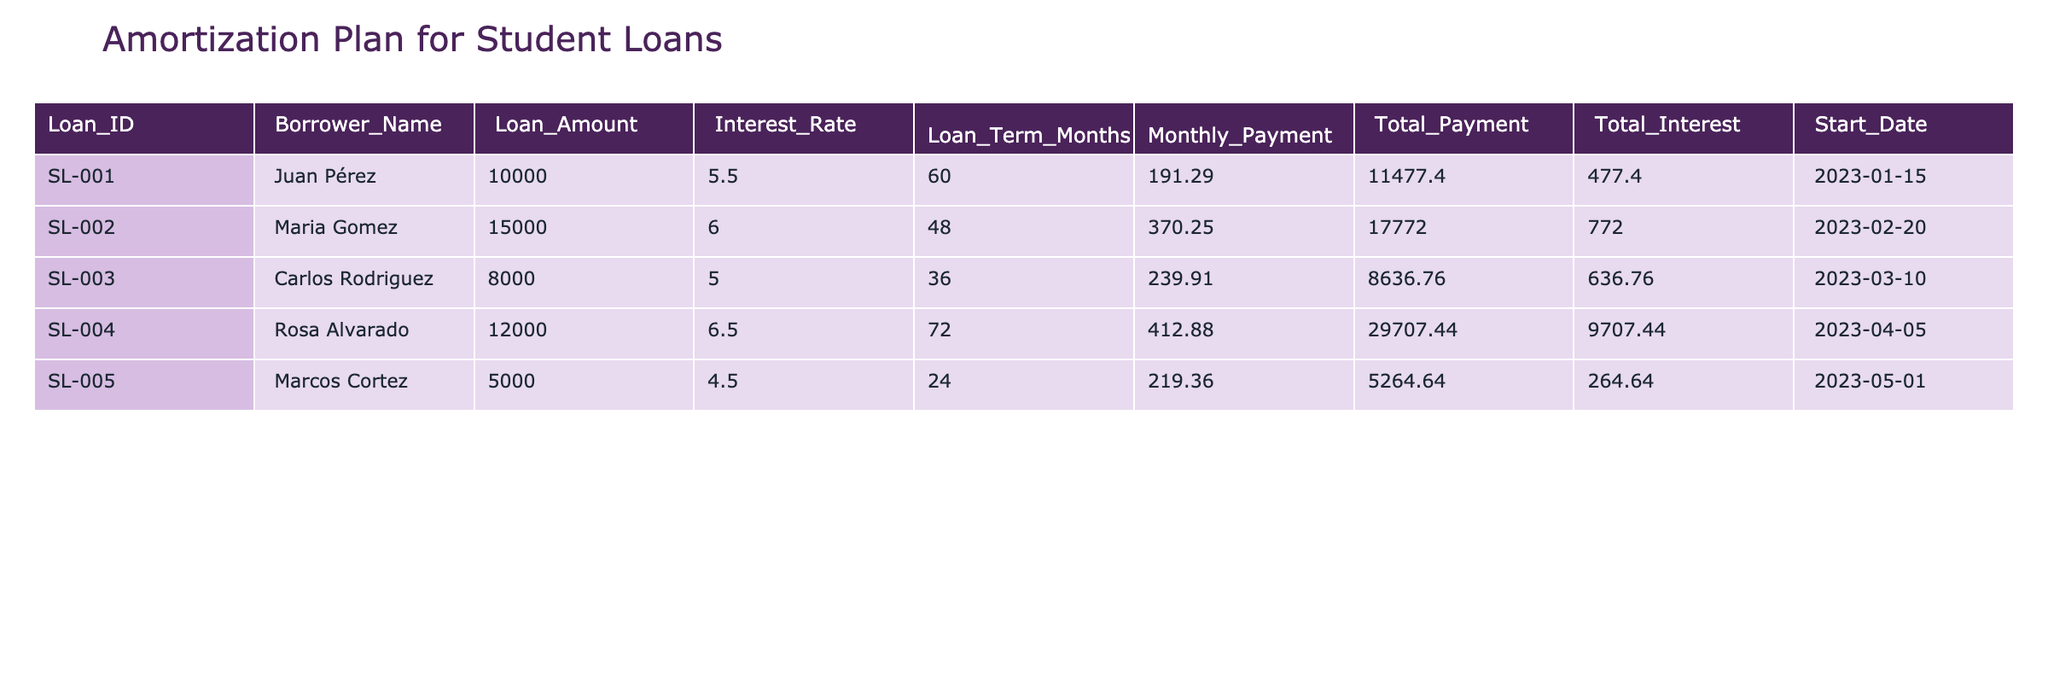What is the total loan amount for all borrowers? To find the total loan amount for all borrowers, we sum the 'Loan_Amount' for each entry in the table: 10000 + 15000 + 8000 + 12000 + 5000 = 50000.
Answer: 50000 Which borrower has the highest monthly payment? By comparing all monthly payments in the table, we see that Rosa Alvarado has the highest monthly payment of 412.88.
Answer: Rosa Alvarado Is the total interest paid by Juan Pérez greater than the total interest paid by Carlos Rodriguez? Juan Pérez paid 477.40 in total interest, while Carlos Rodriguez paid 636.76. Since 477.40 is less than 636.76, the statement is false.
Answer: No What is the average interest rate for all loans? We calculate the average interest rate by summing all the interest rates (5.5 + 6.0 + 5.0 + 6.5 + 4.5 = 27.5) and dividing by the number of loans (5): 27.5 / 5 = 5.5.
Answer: 5.5 How much total payment did Maria Gomez make compared to Marcos Cortez? Maria Gomez made a total payment of 17772.00 and Marcos Cortez made 5264.64. The difference is calculated as 17772.00 - 5264.64 = 12407.36. Thus, Maria Gomez paid 12407.36 more than Marcos Cortez.
Answer: 12407.36 What is the loan term for Carlos Rodriguez, and is it longer than the loan term for Juan Pérez? Carlos Rodriguez has a loan term of 36 months, while Juan Pérez has 60 months. Since 36 is less than 60, the loan term for Carlos Rodriguez is not longer than Juan Pérez's.
Answer: No What is the total payment made by all borrowers combined? To find the total payment, we add all 'Total_Payment' values: 11477.40 + 17772.00 + 8636.76 + 29707.44 + 5264.64 = 73858.24.
Answer: 73858.24 Which borrower has the loan with the lowest interest rate, and what is that rate? By examining the interest rates, Marcos Cortez has the lowest interest rate at 4.5.
Answer: Marcos Cortez, 4.5 Is it true that all borrowers have a loan term of more than a year? All loan terms in the table are either 24, 36, 48, 60, or 72 months. Since all these terms exceed 12 months, the statement is true.
Answer: Yes 